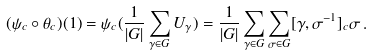Convert formula to latex. <formula><loc_0><loc_0><loc_500><loc_500>( \psi _ { c } \circ \theta _ { c } ) ( 1 ) = \psi _ { c } ( \frac { 1 } { | G | } \sum _ { \gamma \in G } U _ { \gamma } ) = \frac { 1 } { | G | } \sum _ { \gamma \in G } \sum _ { \sigma \in G } [ \gamma , \sigma ^ { - 1 } ] _ { c } \sigma \, .</formula> 